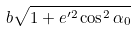Convert formula to latex. <formula><loc_0><loc_0><loc_500><loc_500>b \sqrt { 1 + e ^ { \prime 2 } \cos ^ { 2 } \alpha _ { 0 } }</formula> 